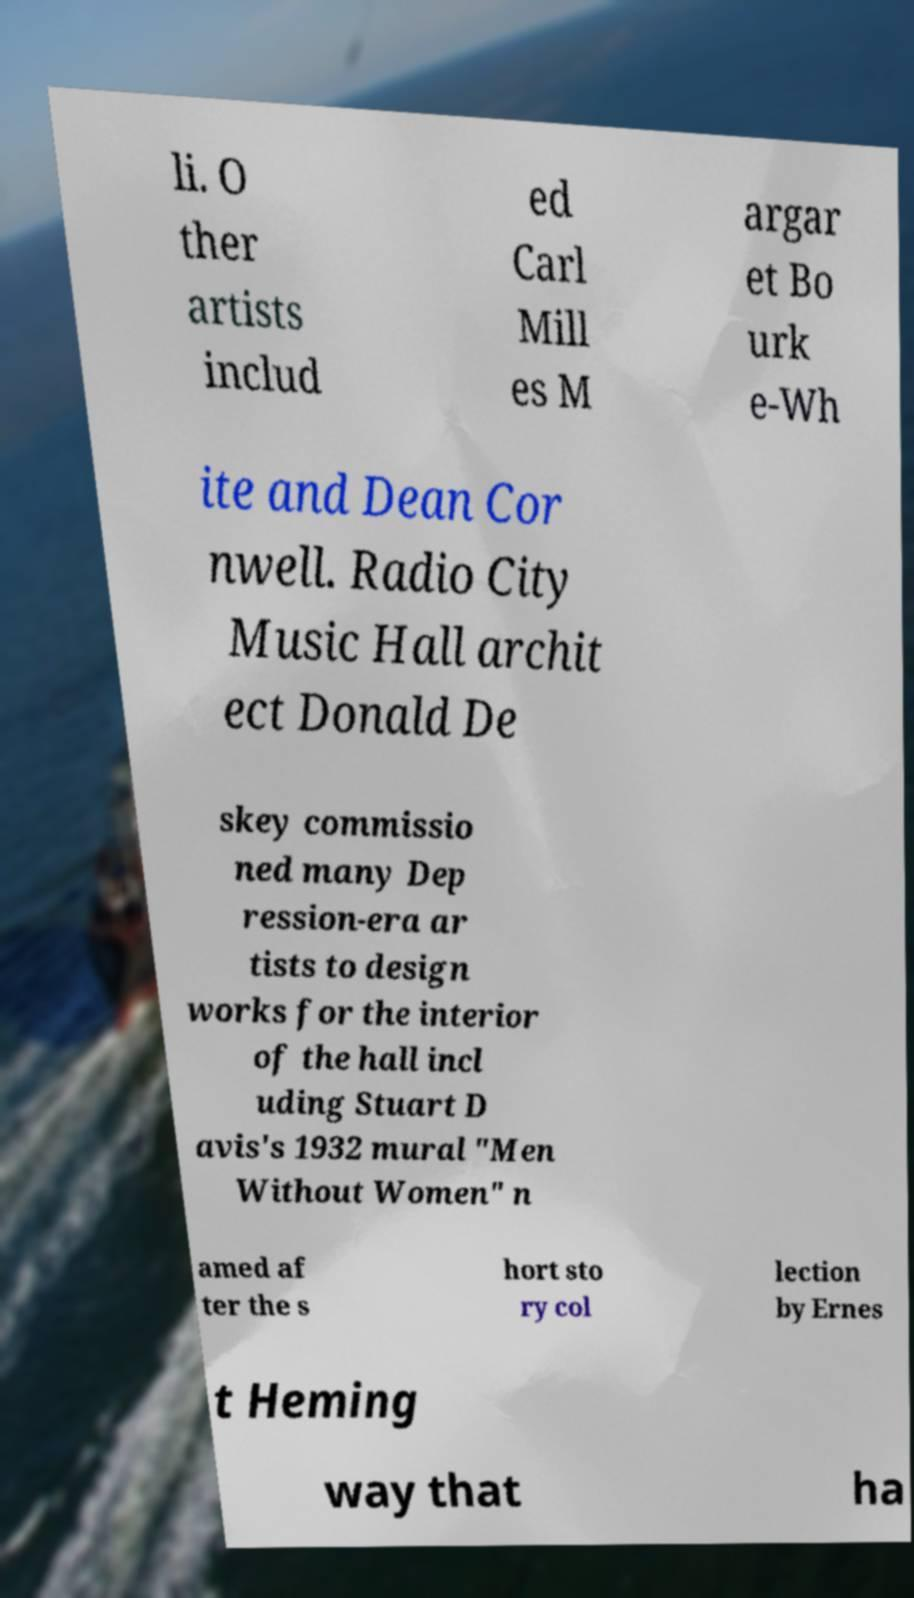There's text embedded in this image that I need extracted. Can you transcribe it verbatim? li. O ther artists includ ed Carl Mill es M argar et Bo urk e-Wh ite and Dean Cor nwell. Radio City Music Hall archit ect Donald De skey commissio ned many Dep ression-era ar tists to design works for the interior of the hall incl uding Stuart D avis's 1932 mural "Men Without Women" n amed af ter the s hort sto ry col lection by Ernes t Heming way that ha 